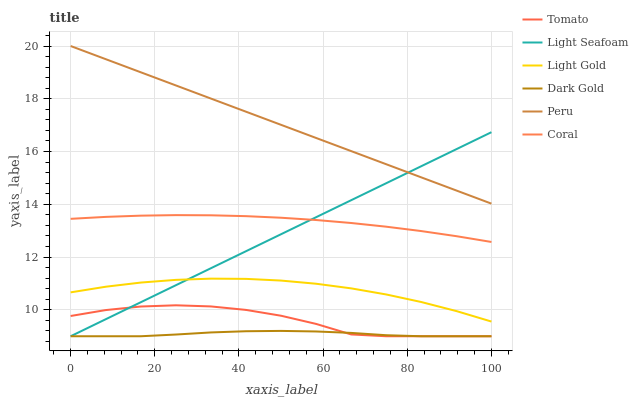Does Coral have the minimum area under the curve?
Answer yes or no. No. Does Coral have the maximum area under the curve?
Answer yes or no. No. Is Dark Gold the smoothest?
Answer yes or no. No. Is Dark Gold the roughest?
Answer yes or no. No. Does Coral have the lowest value?
Answer yes or no. No. Does Coral have the highest value?
Answer yes or no. No. Is Dark Gold less than Peru?
Answer yes or no. Yes. Is Light Gold greater than Tomato?
Answer yes or no. Yes. Does Dark Gold intersect Peru?
Answer yes or no. No. 